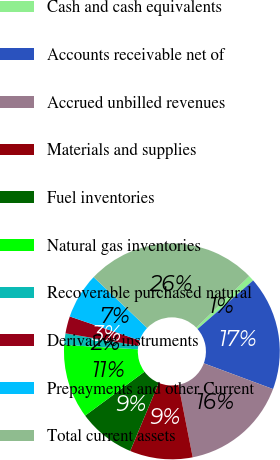<chart> <loc_0><loc_0><loc_500><loc_500><pie_chart><fcel>Cash and cash equivalents<fcel>Accounts receivable net of<fcel>Accrued unbilled revenues<fcel>Materials and supplies<fcel>Fuel inventories<fcel>Natural gas inventories<fcel>Recoverable purchased natural<fcel>Derivative instruments<fcel>Prepayments and other Current<fcel>Total current assets<nl><fcel>0.86%<fcel>17.09%<fcel>16.24%<fcel>9.4%<fcel>8.55%<fcel>11.11%<fcel>1.71%<fcel>2.57%<fcel>6.84%<fcel>25.63%<nl></chart> 